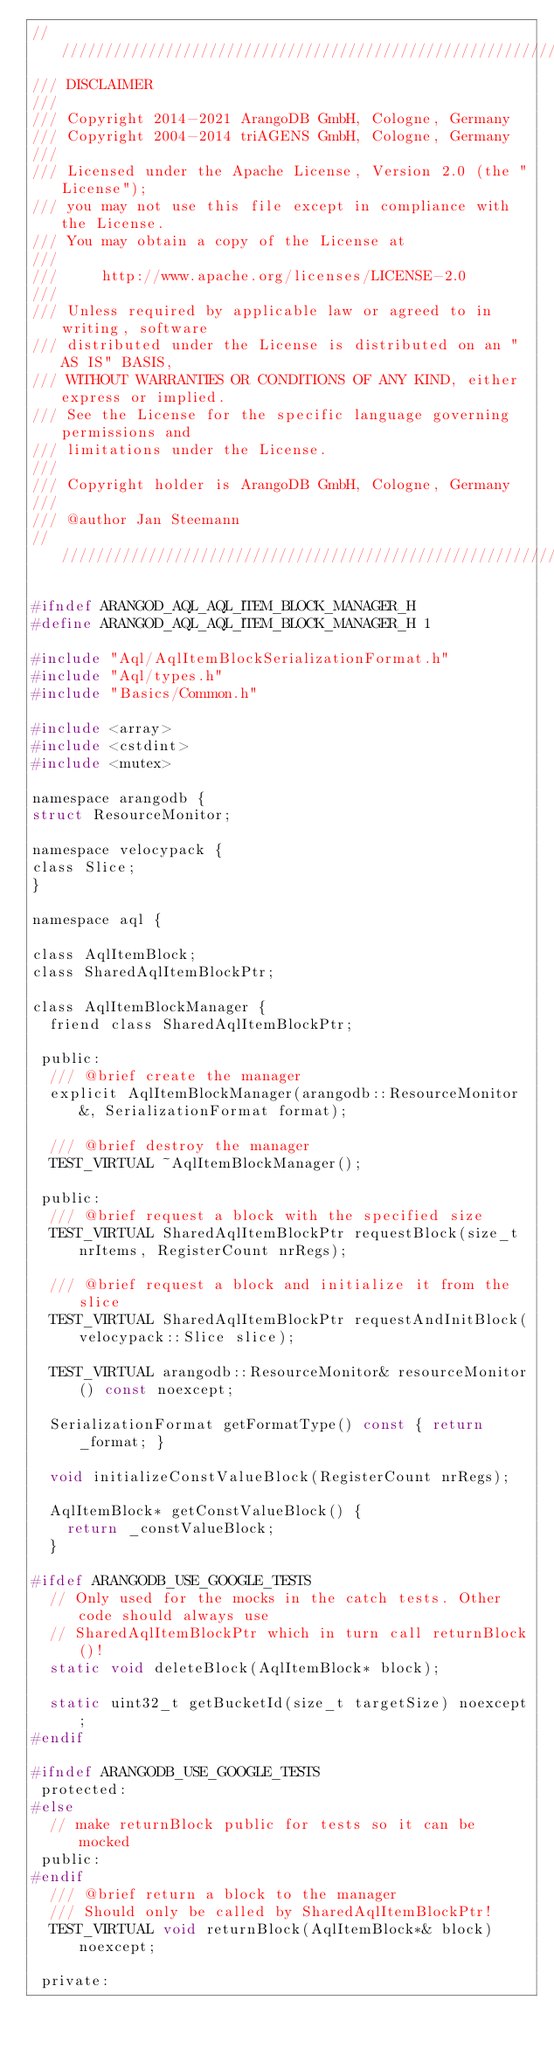Convert code to text. <code><loc_0><loc_0><loc_500><loc_500><_C_>////////////////////////////////////////////////////////////////////////////////
/// DISCLAIMER
///
/// Copyright 2014-2021 ArangoDB GmbH, Cologne, Germany
/// Copyright 2004-2014 triAGENS GmbH, Cologne, Germany
///
/// Licensed under the Apache License, Version 2.0 (the "License");
/// you may not use this file except in compliance with the License.
/// You may obtain a copy of the License at
///
///     http://www.apache.org/licenses/LICENSE-2.0
///
/// Unless required by applicable law or agreed to in writing, software
/// distributed under the License is distributed on an "AS IS" BASIS,
/// WITHOUT WARRANTIES OR CONDITIONS OF ANY KIND, either express or implied.
/// See the License for the specific language governing permissions and
/// limitations under the License.
///
/// Copyright holder is ArangoDB GmbH, Cologne, Germany
///
/// @author Jan Steemann
////////////////////////////////////////////////////////////////////////////////

#ifndef ARANGOD_AQL_AQL_ITEM_BLOCK_MANAGER_H
#define ARANGOD_AQL_AQL_ITEM_BLOCK_MANAGER_H 1

#include "Aql/AqlItemBlockSerializationFormat.h"
#include "Aql/types.h"
#include "Basics/Common.h"

#include <array>
#include <cstdint>
#include <mutex>

namespace arangodb {
struct ResourceMonitor;

namespace velocypack {
class Slice;
}

namespace aql {

class AqlItemBlock;
class SharedAqlItemBlockPtr;

class AqlItemBlockManager {
  friend class SharedAqlItemBlockPtr;

 public:
  /// @brief create the manager
  explicit AqlItemBlockManager(arangodb::ResourceMonitor&, SerializationFormat format);

  /// @brief destroy the manager
  TEST_VIRTUAL ~AqlItemBlockManager();

 public:
  /// @brief request a block with the specified size
  TEST_VIRTUAL SharedAqlItemBlockPtr requestBlock(size_t nrItems, RegisterCount nrRegs);

  /// @brief request a block and initialize it from the slice
  TEST_VIRTUAL SharedAqlItemBlockPtr requestAndInitBlock(velocypack::Slice slice);

  TEST_VIRTUAL arangodb::ResourceMonitor& resourceMonitor() const noexcept;

  SerializationFormat getFormatType() const { return _format; }

  void initializeConstValueBlock(RegisterCount nrRegs);

  AqlItemBlock* getConstValueBlock() {
    return _constValueBlock;
  }

#ifdef ARANGODB_USE_GOOGLE_TESTS
  // Only used for the mocks in the catch tests. Other code should always use
  // SharedAqlItemBlockPtr which in turn call returnBlock()!
  static void deleteBlock(AqlItemBlock* block);

  static uint32_t getBucketId(size_t targetSize) noexcept;
#endif

#ifndef ARANGODB_USE_GOOGLE_TESTS
 protected:
#else
  // make returnBlock public for tests so it can be mocked
 public:
#endif
  /// @brief return a block to the manager
  /// Should only be called by SharedAqlItemBlockPtr!
  TEST_VIRTUAL void returnBlock(AqlItemBlock*& block) noexcept;

 private:</code> 